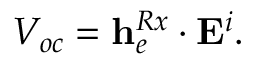Convert formula to latex. <formula><loc_0><loc_0><loc_500><loc_500>V _ { o c } = { h } _ { e } ^ { R x } \cdot { E } ^ { i } .</formula> 